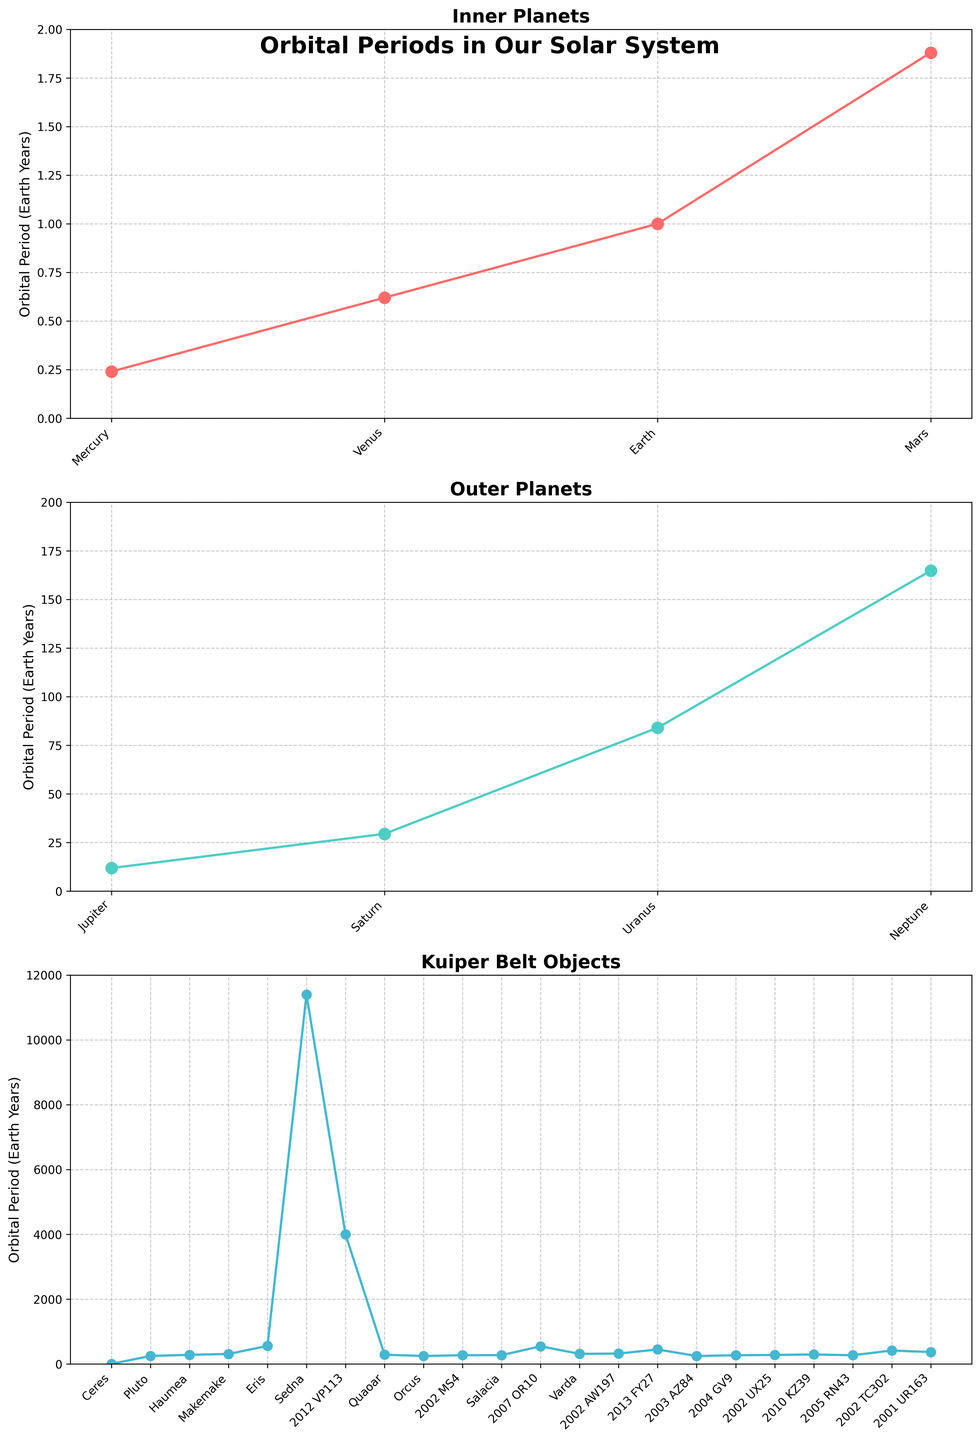What is the orbital period of Neptune? Look at the section for outer planets and find Neptune. The y-axis value corresponding to Neptune represents its orbital period. It reads as approximately 164.79 Earth years.
Answer: 164.79 Earth years Which Kuiper Belt object has the longest orbital period? In the Kuiper Belt subplot, identify the object with the highest point on the graph. The tallest point corresponds to Sedna with an orbital period of approximately 11400 Earth years.
Answer: Sedna Which inner planet has the shortest orbital period? In the Inner Planets subplot, find the object with the lowest value on the y-axis. Mercury is at the lowest point, indicating it has the shortest orbital period of approximately 0.24 Earth years.
Answer: Mercury How does the orbital period of Jupiter compare to that of Saturn? In the Outer Planets subplot, compare the y-axis values for Jupiter and Saturn. Jupiter's orbital period is about 11.86 Earth years, while Saturn's is about 29.46 Earth years. Jupiter's orbital period is thus shorter than Saturn's.
Answer: Jupiter's orbital period is shorter What is the difference in orbital periods between Earth and Mars? Check the Inner Planets subplot for the y-axis values of Earth and Mars. Earth has an orbital period of 1 year, and Mars has 1.88 years. The difference is 1.88 - 1 = 0.88 years.
Answer: 0.88 years Which Kuiper Belt objects have orbital periods greater than 500 Earth years but less than 1000 Earth years? In the Kuiper Belt Objects subplot, locate points between 500 and 1000 on the y-axis. Orcus, 2002 TC302, 2007 OR10, and 2013 FY27 fall within this range.
Answer: Orcus, 2002 TC302, 2007 OR10, 2013 FY27 What is the average orbital period of the inner planets? Find the y-axis values for the inner planets: Mercury (0.24), Venus (0.62), Earth (1.00), and Mars (1.88). Calculate their average: (0.24 + 0.62 + 1.00 + 1.88) / 4 = 0.935 Earth years.
Answer: 0.935 Earth years Compare the orbital period of Quaoar to that of Haumea and determine which is longer. In the Kuiper Belt subplot, find the y-axis values for Quaoar (288) and Haumea (283.80). Quaoar's orbital period is longer.
Answer: Quaoar's orbital period is longer What is the total sum of the orbital periods for the outer planets? Locate the y-axis values for Jupiter, Saturn, Uranus, and Neptune in the Outer Planets subplot. Sum them up: 11.86 + 29.46 + 84.01 + 164.79 = 290.12 Earth years.
Answer: 290.12 Earth years Which Kuiper Belt object has an orbital period close to 300 Earth years? In the Kuiper Belt subplot, find the point with a y-axis value near 300. Quaoar (288), Salacia (273.98), and Varda (313.12) are closest, where Quaoar is the closest.
Answer: Quaoar 